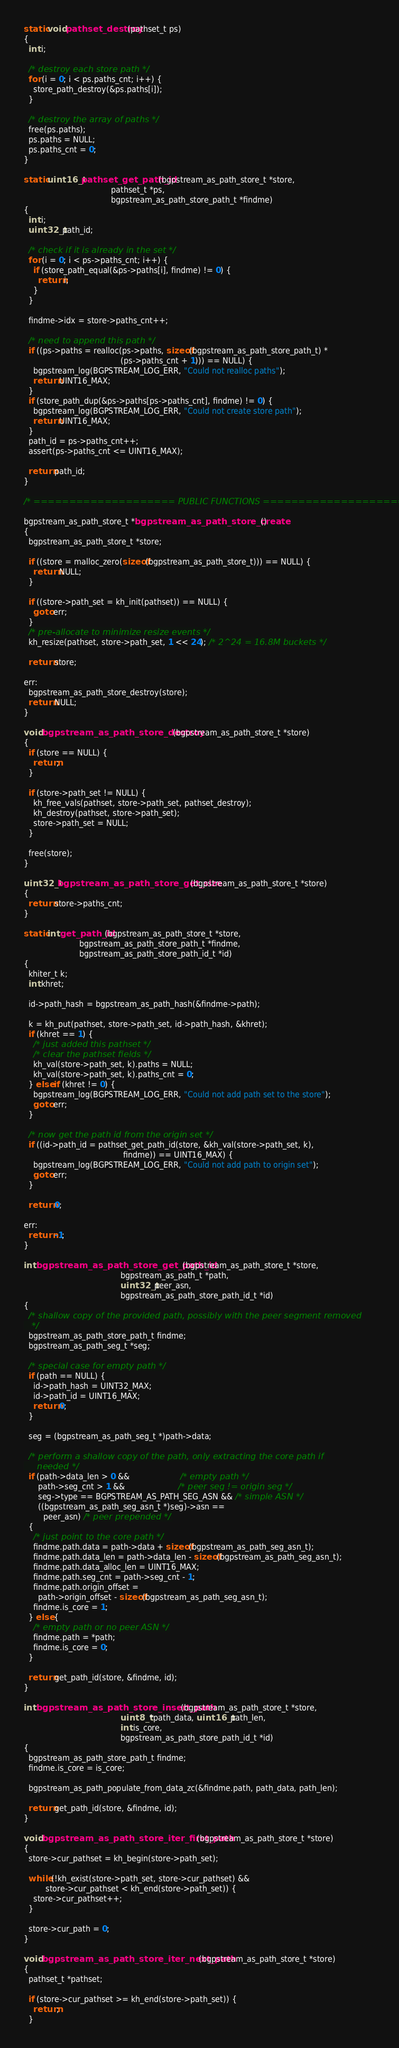<code> <loc_0><loc_0><loc_500><loc_500><_C_>static void pathset_destroy(pathset_t ps)
{
  int i;

  /* destroy each store path */
  for (i = 0; i < ps.paths_cnt; i++) {
    store_path_destroy(&ps.paths[i]);
  }

  /* destroy the array of paths */
  free(ps.paths);
  ps.paths = NULL;
  ps.paths_cnt = 0;
}

static uint16_t pathset_get_path_id(bgpstream_as_path_store_t *store,
                                    pathset_t *ps,
                                    bgpstream_as_path_store_path_t *findme)
{
  int i;
  uint32_t path_id;

  /* check if it is already in the set */
  for (i = 0; i < ps->paths_cnt; i++) {
    if (store_path_equal(&ps->paths[i], findme) != 0) {
      return i;
    }
  }

  findme->idx = store->paths_cnt++;

  /* need to append this path */
  if ((ps->paths = realloc(ps->paths, sizeof(bgpstream_as_path_store_path_t) *
                                        (ps->paths_cnt + 1))) == NULL) {
    bgpstream_log(BGPSTREAM_LOG_ERR, "Could not realloc paths");
    return UINT16_MAX;
  }
  if (store_path_dup(&ps->paths[ps->paths_cnt], findme) != 0) {
    bgpstream_log(BGPSTREAM_LOG_ERR, "Could not create store path");
    return UINT16_MAX;
  }
  path_id = ps->paths_cnt++;
  assert(ps->paths_cnt <= UINT16_MAX);

  return path_id;
}

/* ==================== PUBLIC FUNCTIONS ==================== */

bgpstream_as_path_store_t *bgpstream_as_path_store_create()
{
  bgpstream_as_path_store_t *store;

  if ((store = malloc_zero(sizeof(bgpstream_as_path_store_t))) == NULL) {
    return NULL;
  }

  if ((store->path_set = kh_init(pathset)) == NULL) {
    goto err;
  }
  /* pre-allocate to minimize resize events */
  kh_resize(pathset, store->path_set, 1 << 24); /* 2^24 = 16.8M buckets */

  return store;

err:
  bgpstream_as_path_store_destroy(store);
  return NULL;
}

void bgpstream_as_path_store_destroy(bgpstream_as_path_store_t *store)
{
  if (store == NULL) {
    return;
  }

  if (store->path_set != NULL) {
    kh_free_vals(pathset, store->path_set, pathset_destroy);
    kh_destroy(pathset, store->path_set);
    store->path_set = NULL;
  }

  free(store);
}

uint32_t bgpstream_as_path_store_get_size(bgpstream_as_path_store_t *store)
{
  return store->paths_cnt;
}

static int get_path_id(bgpstream_as_path_store_t *store,
                       bgpstream_as_path_store_path_t *findme,
                       bgpstream_as_path_store_path_id_t *id)
{
  khiter_t k;
  int khret;

  id->path_hash = bgpstream_as_path_hash(&findme->path);

  k = kh_put(pathset, store->path_set, id->path_hash, &khret);
  if (khret == 1) {
    /* just added this pathset */
    /* clear the pathset fields */
    kh_val(store->path_set, k).paths = NULL;
    kh_val(store->path_set, k).paths_cnt = 0;
  } else if (khret != 0) {
    bgpstream_log(BGPSTREAM_LOG_ERR, "Could not add path set to the store");
    goto err;
  }

  /* now get the path id from the origin set */
  if ((id->path_id = pathset_get_path_id(store, &kh_val(store->path_set, k),
                                         findme)) == UINT16_MAX) {
    bgpstream_log(BGPSTREAM_LOG_ERR, "Could not add path to origin set");
    goto err;
  }

  return 0;

err:
  return -1;
}

int bgpstream_as_path_store_get_path_id(bgpstream_as_path_store_t *store,
                                        bgpstream_as_path_t *path,
                                        uint32_t peer_asn,
                                        bgpstream_as_path_store_path_id_t *id)
{
  /* shallow copy of the provided path, possibly with the peer segment removed
   */
  bgpstream_as_path_store_path_t findme;
  bgpstream_as_path_seg_t *seg;

  /* special case for empty path */
  if (path == NULL) {
    id->path_hash = UINT32_MAX;
    id->path_id = UINT16_MAX;
    return 0;
  }

  seg = (bgpstream_as_path_seg_t *)path->data;

  /* perform a shallow copy of the path, only extracting the core path if
     needed */
  if (path->data_len > 0 &&                     /* empty path */
      path->seg_cnt > 1 &&                      /* peer seg != origin seg */
      seg->type == BGPSTREAM_AS_PATH_SEG_ASN && /* simple ASN */
      ((bgpstream_as_path_seg_asn_t *)seg)->asn ==
        peer_asn) /* peer prepended */
  {
    /* just point to the core path */
    findme.path.data = path->data + sizeof(bgpstream_as_path_seg_asn_t);
    findme.path.data_len = path->data_len - sizeof(bgpstream_as_path_seg_asn_t);
    findme.path.data_alloc_len = UINT16_MAX;
    findme.path.seg_cnt = path->seg_cnt - 1;
    findme.path.origin_offset =
      path->origin_offset - sizeof(bgpstream_as_path_seg_asn_t);
    findme.is_core = 1;
  } else {
    /* empty path or no peer ASN */
    findme.path = *path;
    findme.is_core = 0;
  }

  return get_path_id(store, &findme, id);
}

int bgpstream_as_path_store_insert_path(bgpstream_as_path_store_t *store,
                                        uint8_t *path_data, uint16_t path_len,
                                        int is_core,
                                        bgpstream_as_path_store_path_id_t *id)
{
  bgpstream_as_path_store_path_t findme;
  findme.is_core = is_core;

  bgpstream_as_path_populate_from_data_zc(&findme.path, path_data, path_len);

  return get_path_id(store, &findme, id);
}

void bgpstream_as_path_store_iter_first_path(bgpstream_as_path_store_t *store)
{
  store->cur_pathset = kh_begin(store->path_set);

  while (!kh_exist(store->path_set, store->cur_pathset) &&
         store->cur_pathset < kh_end(store->path_set)) {
    store->cur_pathset++;
  }

  store->cur_path = 0;
}

void bgpstream_as_path_store_iter_next_path(bgpstream_as_path_store_t *store)
{
  pathset_t *pathset;

  if (store->cur_pathset >= kh_end(store->path_set)) {
    return;
  }
</code> 